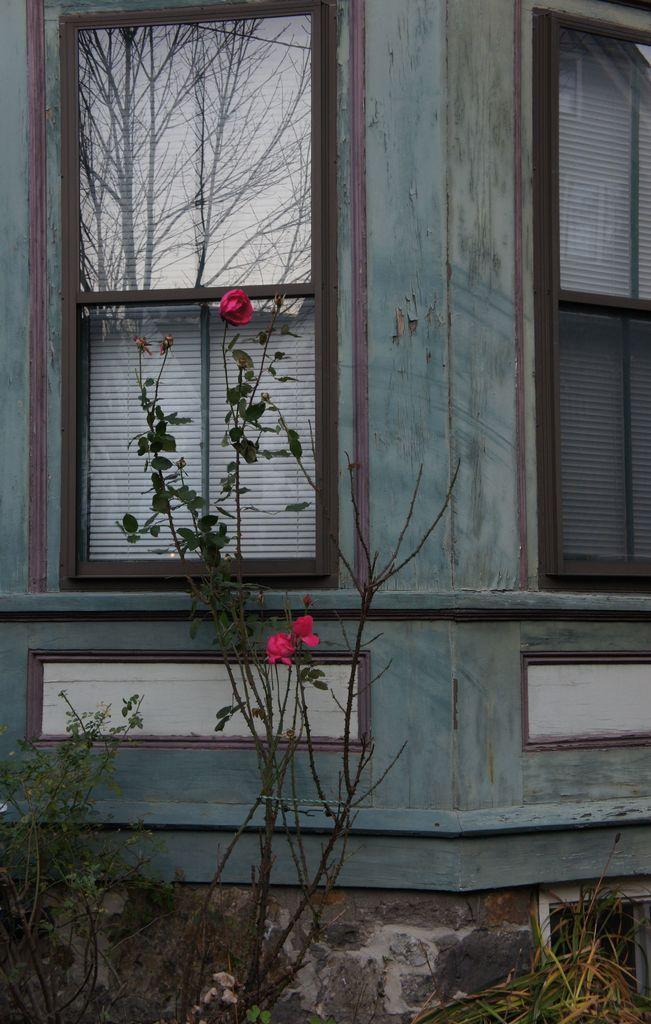Could you give a brief overview of what you see in this image? In this image, there are plants and I can see the windows to a wall. I can see the reflection of trees and the sky on a glass window. 